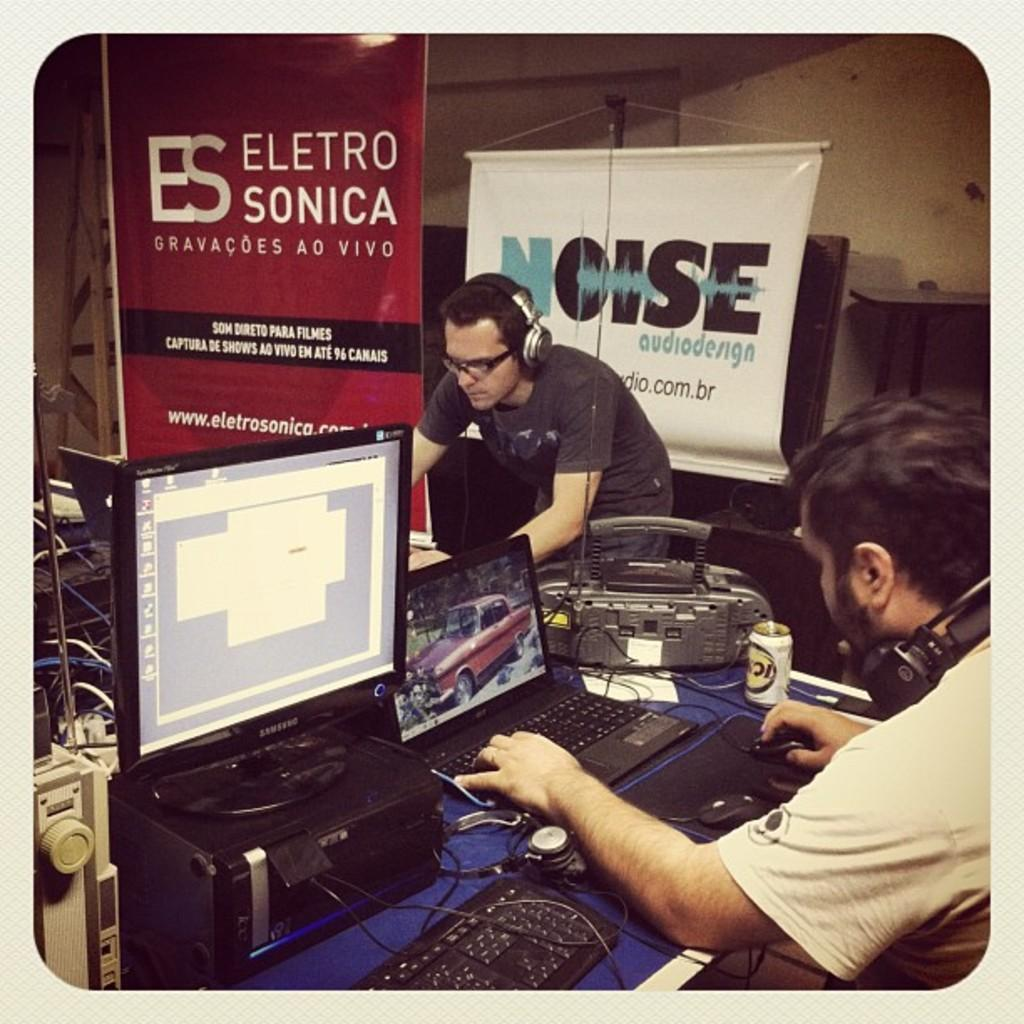What type of electronic device is on the table in the image? There is a monitor, laptops, a printer, a keyboard, a mouse, and a headset on the table in the image. What is the purpose of the headset? The headset is used for audio communication, as people are wearing headsets in the image. What is the background of the image? There is a wall in the background of the image. How many devices are visible on the table? There are seven devices visible on the table, including the monitor, laptops, printer, keyboard, mouse, headset, and an unspecified device. What type of boot is visible in the image? There is no boot present in the image. 